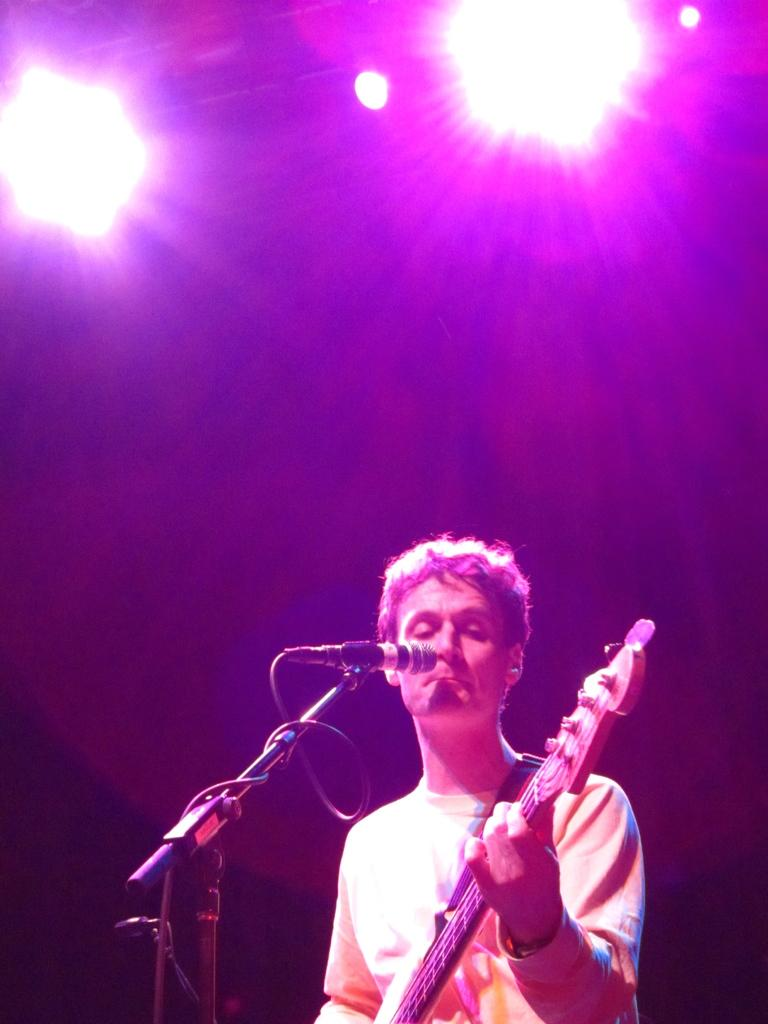What is the person in the image doing? The person is holding a guitar. What other objects related to music can be seen in the image? There is a microphone and a microphone stand in the image. What advice is the person giving to the house in the image? There is no house present in the image, and the person is not giving any advice. 